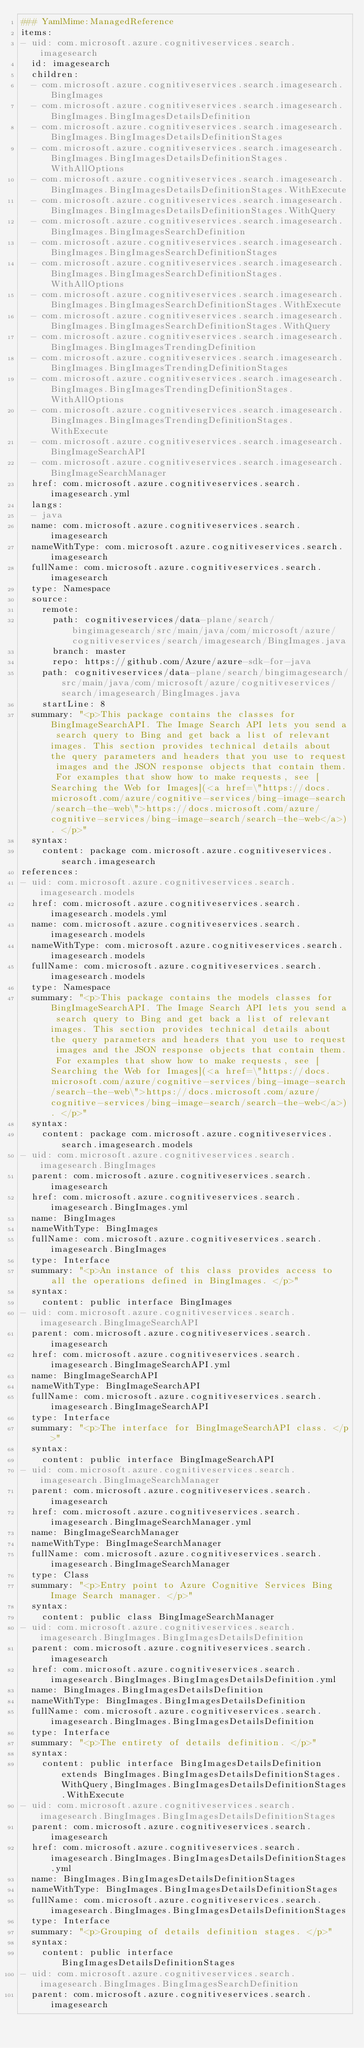<code> <loc_0><loc_0><loc_500><loc_500><_YAML_>### YamlMime:ManagedReference
items:
- uid: com.microsoft.azure.cognitiveservices.search.imagesearch
  id: imagesearch
  children:
  - com.microsoft.azure.cognitiveservices.search.imagesearch.BingImages
  - com.microsoft.azure.cognitiveservices.search.imagesearch.BingImages.BingImagesDetailsDefinition
  - com.microsoft.azure.cognitiveservices.search.imagesearch.BingImages.BingImagesDetailsDefinitionStages
  - com.microsoft.azure.cognitiveservices.search.imagesearch.BingImages.BingImagesDetailsDefinitionStages.WithAllOptions
  - com.microsoft.azure.cognitiveservices.search.imagesearch.BingImages.BingImagesDetailsDefinitionStages.WithExecute
  - com.microsoft.azure.cognitiveservices.search.imagesearch.BingImages.BingImagesDetailsDefinitionStages.WithQuery
  - com.microsoft.azure.cognitiveservices.search.imagesearch.BingImages.BingImagesSearchDefinition
  - com.microsoft.azure.cognitiveservices.search.imagesearch.BingImages.BingImagesSearchDefinitionStages
  - com.microsoft.azure.cognitiveservices.search.imagesearch.BingImages.BingImagesSearchDefinitionStages.WithAllOptions
  - com.microsoft.azure.cognitiveservices.search.imagesearch.BingImages.BingImagesSearchDefinitionStages.WithExecute
  - com.microsoft.azure.cognitiveservices.search.imagesearch.BingImages.BingImagesSearchDefinitionStages.WithQuery
  - com.microsoft.azure.cognitiveservices.search.imagesearch.BingImages.BingImagesTrendingDefinition
  - com.microsoft.azure.cognitiveservices.search.imagesearch.BingImages.BingImagesTrendingDefinitionStages
  - com.microsoft.azure.cognitiveservices.search.imagesearch.BingImages.BingImagesTrendingDefinitionStages.WithAllOptions
  - com.microsoft.azure.cognitiveservices.search.imagesearch.BingImages.BingImagesTrendingDefinitionStages.WithExecute
  - com.microsoft.azure.cognitiveservices.search.imagesearch.BingImageSearchAPI
  - com.microsoft.azure.cognitiveservices.search.imagesearch.BingImageSearchManager
  href: com.microsoft.azure.cognitiveservices.search.imagesearch.yml
  langs:
  - java
  name: com.microsoft.azure.cognitiveservices.search.imagesearch
  nameWithType: com.microsoft.azure.cognitiveservices.search.imagesearch
  fullName: com.microsoft.azure.cognitiveservices.search.imagesearch
  type: Namespace
  source:
    remote:
      path: cognitiveservices/data-plane/search/bingimagesearch/src/main/java/com/microsoft/azure/cognitiveservices/search/imagesearch/BingImages.java
      branch: master
      repo: https://github.com/Azure/azure-sdk-for-java
    path: cognitiveservices/data-plane/search/bingimagesearch/src/main/java/com/microsoft/azure/cognitiveservices/search/imagesearch/BingImages.java
    startLine: 8
  summary: "<p>This package contains the classes for BingImageSearchAPI. The Image Search API lets you send a search query to Bing and get back a list of relevant images. This section provides technical details about the query parameters and headers that you use to request images and the JSON response objects that contain them. For examples that show how to make requests, see [Searching the Web for Images](<a href=\"https://docs.microsoft.com/azure/cognitive-services/bing-image-search/search-the-web\">https://docs.microsoft.com/azure/cognitive-services/bing-image-search/search-the-web</a>). </p>"
  syntax:
    content: package com.microsoft.azure.cognitiveservices.search.imagesearch
references:
- uid: com.microsoft.azure.cognitiveservices.search.imagesearch.models
  href: com.microsoft.azure.cognitiveservices.search.imagesearch.models.yml
  name: com.microsoft.azure.cognitiveservices.search.imagesearch.models
  nameWithType: com.microsoft.azure.cognitiveservices.search.imagesearch.models
  fullName: com.microsoft.azure.cognitiveservices.search.imagesearch.models
  type: Namespace
  summary: "<p>This package contains the models classes for BingImageSearchAPI. The Image Search API lets you send a search query to Bing and get back a list of relevant images. This section provides technical details about the query parameters and headers that you use to request images and the JSON response objects that contain them. For examples that show how to make requests, see [Searching the Web for Images](<a href=\"https://docs.microsoft.com/azure/cognitive-services/bing-image-search/search-the-web\">https://docs.microsoft.com/azure/cognitive-services/bing-image-search/search-the-web</a>). </p>"
  syntax:
    content: package com.microsoft.azure.cognitiveservices.search.imagesearch.models
- uid: com.microsoft.azure.cognitiveservices.search.imagesearch.BingImages
  parent: com.microsoft.azure.cognitiveservices.search.imagesearch
  href: com.microsoft.azure.cognitiveservices.search.imagesearch.BingImages.yml
  name: BingImages
  nameWithType: BingImages
  fullName: com.microsoft.azure.cognitiveservices.search.imagesearch.BingImages
  type: Interface
  summary: "<p>An instance of this class provides access to all the operations defined in BingImages. </p>"
  syntax:
    content: public interface BingImages
- uid: com.microsoft.azure.cognitiveservices.search.imagesearch.BingImageSearchAPI
  parent: com.microsoft.azure.cognitiveservices.search.imagesearch
  href: com.microsoft.azure.cognitiveservices.search.imagesearch.BingImageSearchAPI.yml
  name: BingImageSearchAPI
  nameWithType: BingImageSearchAPI
  fullName: com.microsoft.azure.cognitiveservices.search.imagesearch.BingImageSearchAPI
  type: Interface
  summary: "<p>The interface for BingImageSearchAPI class. </p>"
  syntax:
    content: public interface BingImageSearchAPI
- uid: com.microsoft.azure.cognitiveservices.search.imagesearch.BingImageSearchManager
  parent: com.microsoft.azure.cognitiveservices.search.imagesearch
  href: com.microsoft.azure.cognitiveservices.search.imagesearch.BingImageSearchManager.yml
  name: BingImageSearchManager
  nameWithType: BingImageSearchManager
  fullName: com.microsoft.azure.cognitiveservices.search.imagesearch.BingImageSearchManager
  type: Class
  summary: "<p>Entry point to Azure Cognitive Services Bing Image Search manager. </p>"
  syntax:
    content: public class BingImageSearchManager
- uid: com.microsoft.azure.cognitiveservices.search.imagesearch.BingImages.BingImagesDetailsDefinition
  parent: com.microsoft.azure.cognitiveservices.search.imagesearch
  href: com.microsoft.azure.cognitiveservices.search.imagesearch.BingImages.BingImagesDetailsDefinition.yml
  name: BingImages.BingImagesDetailsDefinition
  nameWithType: BingImages.BingImagesDetailsDefinition
  fullName: com.microsoft.azure.cognitiveservices.search.imagesearch.BingImages.BingImagesDetailsDefinition
  type: Interface
  summary: "<p>The entirety of details definition. </p>"
  syntax:
    content: public interface BingImagesDetailsDefinition extends BingImages.BingImagesDetailsDefinitionStages.WithQuery,BingImages.BingImagesDetailsDefinitionStages.WithExecute
- uid: com.microsoft.azure.cognitiveservices.search.imagesearch.BingImages.BingImagesDetailsDefinitionStages
  parent: com.microsoft.azure.cognitiveservices.search.imagesearch
  href: com.microsoft.azure.cognitiveservices.search.imagesearch.BingImages.BingImagesDetailsDefinitionStages.yml
  name: BingImages.BingImagesDetailsDefinitionStages
  nameWithType: BingImages.BingImagesDetailsDefinitionStages
  fullName: com.microsoft.azure.cognitiveservices.search.imagesearch.BingImages.BingImagesDetailsDefinitionStages
  type: Interface
  summary: "<p>Grouping of details definition stages. </p>"
  syntax:
    content: public interface BingImagesDetailsDefinitionStages
- uid: com.microsoft.azure.cognitiveservices.search.imagesearch.BingImages.BingImagesSearchDefinition
  parent: com.microsoft.azure.cognitiveservices.search.imagesearch</code> 